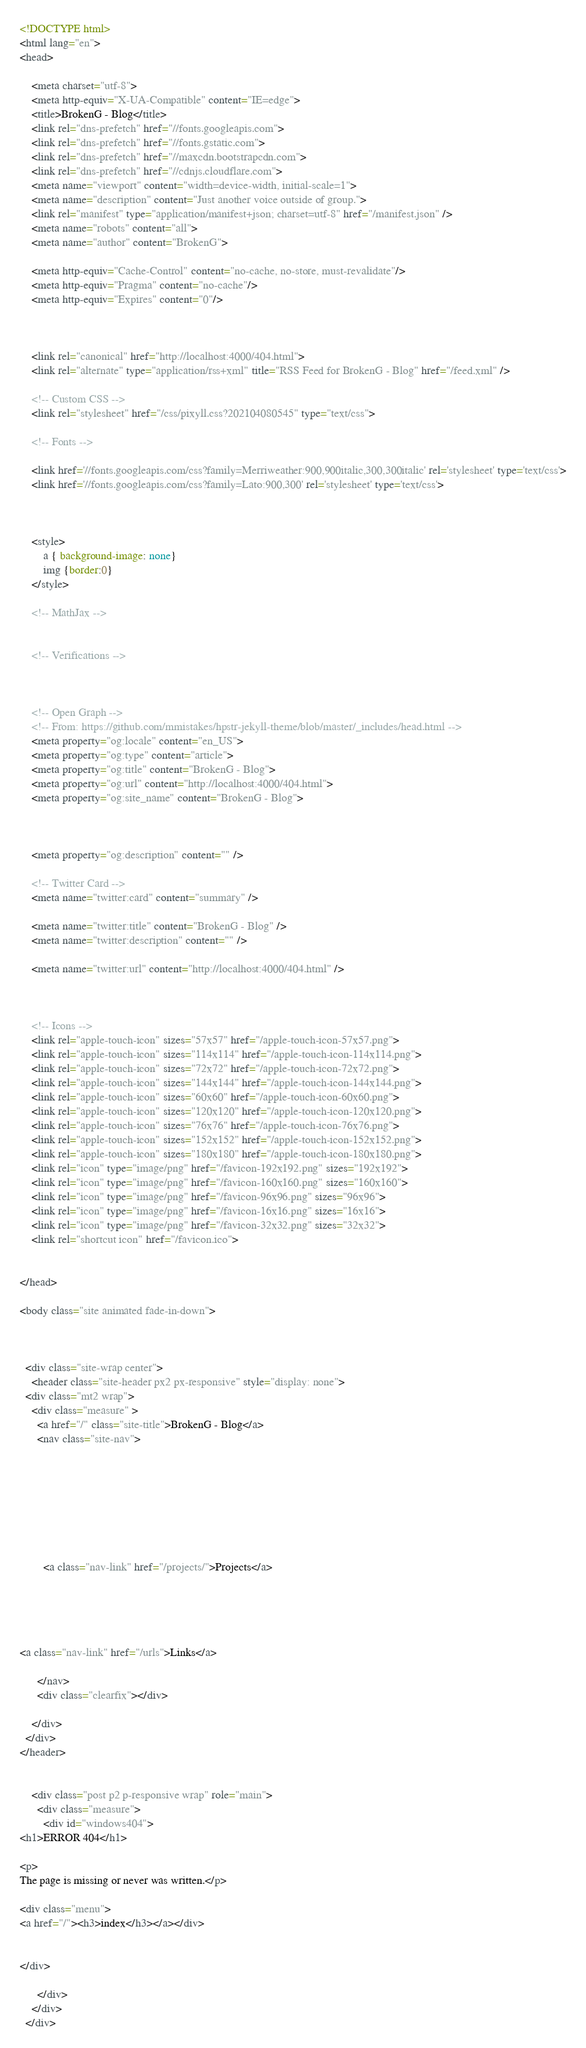Convert code to text. <code><loc_0><loc_0><loc_500><loc_500><_HTML_><!DOCTYPE html>
<html lang="en">
<head>
    
    <meta charset="utf-8">
    <meta http-equiv="X-UA-Compatible" content="IE=edge">
    <title>BrokenG - Blog</title>
    <link rel="dns-prefetch" href="//fonts.googleapis.com">
    <link rel="dns-prefetch" href="//fonts.gstatic.com">
    <link rel="dns-prefetch" href="//maxcdn.bootstrapcdn.com">
    <link rel="dns-prefetch" href="//cdnjs.cloudflare.com">
    <meta name="viewport" content="width=device-width, initial-scale=1">
    <meta name="description" content="Just another voice outside of group.">
    <link rel="manifest" type="application/manifest+json; charset=utf-8" href="/manifest.json" />
    <meta name="robots" content="all">
    <meta name="author" content="BrokenG">

    <meta http-equiv="Cache-Control" content="no-cache, no-store, must-revalidate"/>
    <meta http-equiv="Pragma" content="no-cache"/>
    <meta http-equiv="Expires" content="0"/>

    
    
    <link rel="canonical" href="http://localhost:4000/404.html">
    <link rel="alternate" type="application/rss+xml" title="RSS Feed for BrokenG - Blog" href="/feed.xml" />

    <!-- Custom CSS -->
    <link rel="stylesheet" href="/css/pixyll.css?202104080545" type="text/css">

    <!-- Fonts -->
    
    <link href='//fonts.googleapis.com/css?family=Merriweather:900,900italic,300,300italic' rel='stylesheet' type='text/css'>
    <link href='//fonts.googleapis.com/css?family=Lato:900,300' rel='stylesheet' type='text/css'>
    
    

    <style>
        a { background-image: none}
        img {border:0}
    </style>

    <!-- MathJax -->
    

    <!-- Verifications -->
    
    

    <!-- Open Graph -->
    <!-- From: https://github.com/mmistakes/hpstr-jekyll-theme/blob/master/_includes/head.html -->
    <meta property="og:locale" content="en_US">
    <meta property="og:type" content="article">
    <meta property="og:title" content="BrokenG - Blog">
    <meta property="og:url" content="http://localhost:4000/404.html">
    <meta property="og:site_name" content="BrokenG - Blog">

    

    <meta property="og:description" content="" />

    <!-- Twitter Card -->
    <meta name="twitter:card" content="summary" />
    
    <meta name="twitter:title" content="BrokenG - Blog" />
    <meta name="twitter:description" content="" />

    <meta name="twitter:url" content="http://localhost:4000/404.html" />

    

    <!-- Icons -->
    <link rel="apple-touch-icon" sizes="57x57" href="/apple-touch-icon-57x57.png">
    <link rel="apple-touch-icon" sizes="114x114" href="/apple-touch-icon-114x114.png">
    <link rel="apple-touch-icon" sizes="72x72" href="/apple-touch-icon-72x72.png">
    <link rel="apple-touch-icon" sizes="144x144" href="/apple-touch-icon-144x144.png">
    <link rel="apple-touch-icon" sizes="60x60" href="/apple-touch-icon-60x60.png">
    <link rel="apple-touch-icon" sizes="120x120" href="/apple-touch-icon-120x120.png">
    <link rel="apple-touch-icon" sizes="76x76" href="/apple-touch-icon-76x76.png">
    <link rel="apple-touch-icon" sizes="152x152" href="/apple-touch-icon-152x152.png">
    <link rel="apple-touch-icon" sizes="180x180" href="/apple-touch-icon-180x180.png">
    <link rel="icon" type="image/png" href="/favicon-192x192.png" sizes="192x192">
    <link rel="icon" type="image/png" href="/favicon-160x160.png" sizes="160x160">
    <link rel="icon" type="image/png" href="/favicon-96x96.png" sizes="96x96">
    <link rel="icon" type="image/png" href="/favicon-16x16.png" sizes="16x16">
    <link rel="icon" type="image/png" href="/favicon-32x32.png" sizes="32x32">
    <link rel="shortcut icon" href="/favicon.ico">

    
</head>

<body class="site animated fade-in-down">
  
	

  <div class="site-wrap center">
    <header class="site-header px2 px-responsive" style="display: none">
  <div class="mt2 wrap">
    <div class="measure" >
      <a href="/" class="site-title">BrokenG - Blog</a>
      <nav class="site-nav">
        



    
    
    
    
        <a class="nav-link" href="/projects/">Projects</a>
    

    


<a class="nav-link" href="/urls">Links</a>

      </nav>
      <div class="clearfix"></div>
      
    </div>
  </div>
</header>


    <div class="post p2 p-responsive wrap" role="main">
      <div class="measure">
        <div id="windows404">
<h1>ERROR 404</h1>

<p>
The page is missing or never was written.</p>

<div class="menu">
<a href="/"><h3>index</h3></a></div>


</div>

      </div>
    </div>
  </div>
</code> 